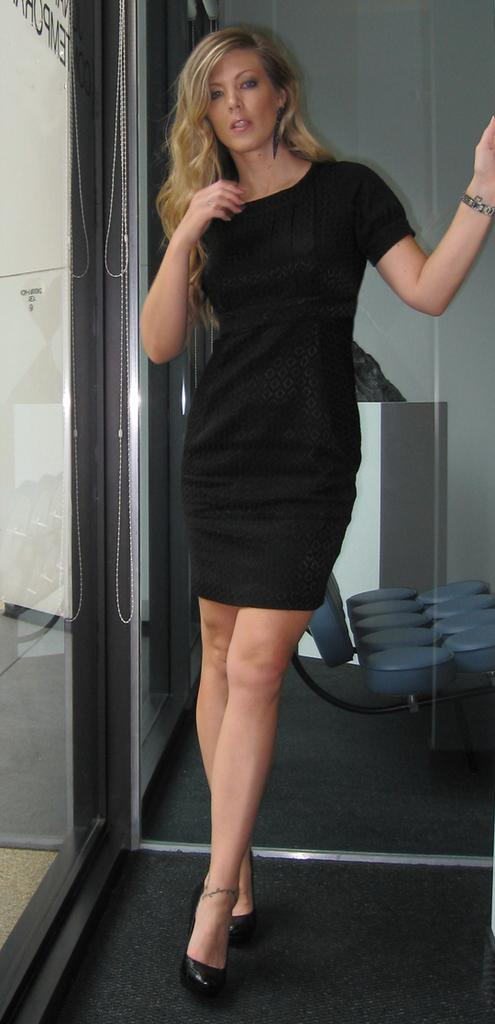Who is the main subject in the image? There is a woman in the image. What is the woman wearing? The woman is wearing a black frock. What is the woman standing on? The woman is standing on a carpet. What can be seen in the background of the image? There is a chair, board, or cupboard, as well as a door in the background of the image. How far away is the jam from the woman in the image? There is no jam present in the image, so it cannot be determined how far away it is from the woman. 